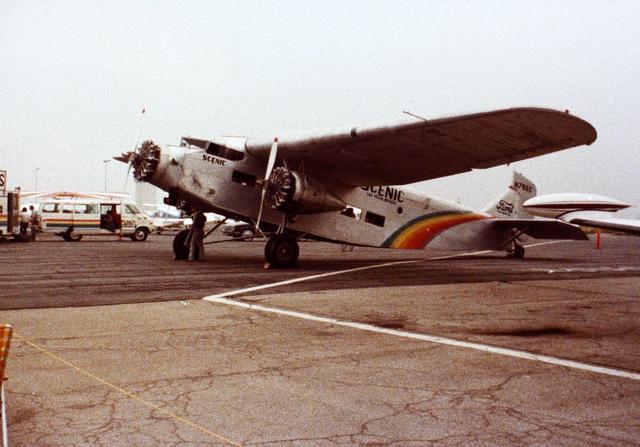How many wheels on the plane?
Give a very brief answer. 3. How many propellers does the airplane have?
Give a very brief answer. 2. 